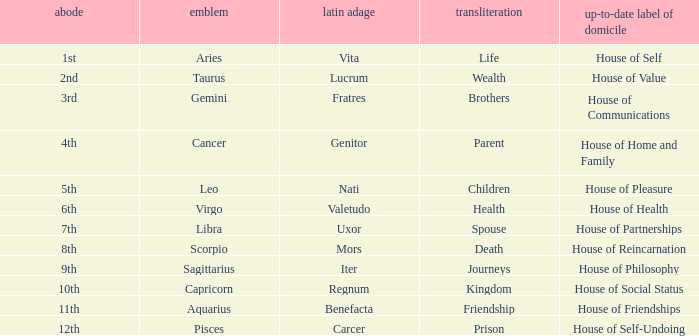What is the translation of the sign of Aquarius? Friendship. 